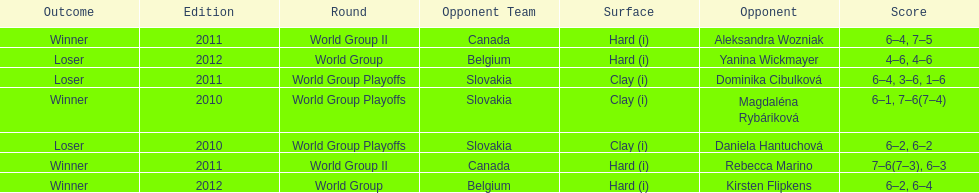Parse the full table. {'header': ['Outcome', 'Edition', 'Round', 'Opponent Team', 'Surface', 'Opponent', 'Score'], 'rows': [['Winner', '2011', 'World Group II', 'Canada', 'Hard (i)', 'Aleksandra Wozniak', '6–4, 7–5'], ['Loser', '2012', 'World Group', 'Belgium', 'Hard (i)', 'Yanina Wickmayer', '4–6, 4–6'], ['Loser', '2011', 'World Group Playoffs', 'Slovakia', 'Clay (i)', 'Dominika Cibulková', '6–4, 3–6, 1–6'], ['Winner', '2010', 'World Group Playoffs', 'Slovakia', 'Clay (i)', 'Magdaléna Rybáriková', '6–1, 7–6(7–4)'], ['Loser', '2010', 'World Group Playoffs', 'Slovakia', 'Clay (i)', 'Daniela Hantuchová', '6–2, 6–2'], ['Winner', '2011', 'World Group II', 'Canada', 'Hard (i)', 'Rebecca Marino', '7–6(7–3), 6–3'], ['Winner', '2012', 'World Group', 'Belgium', 'Hard (i)', 'Kirsten Flipkens', '6–2, 6–4']]} Did they beat canada in more or less than 3 matches? Less. 